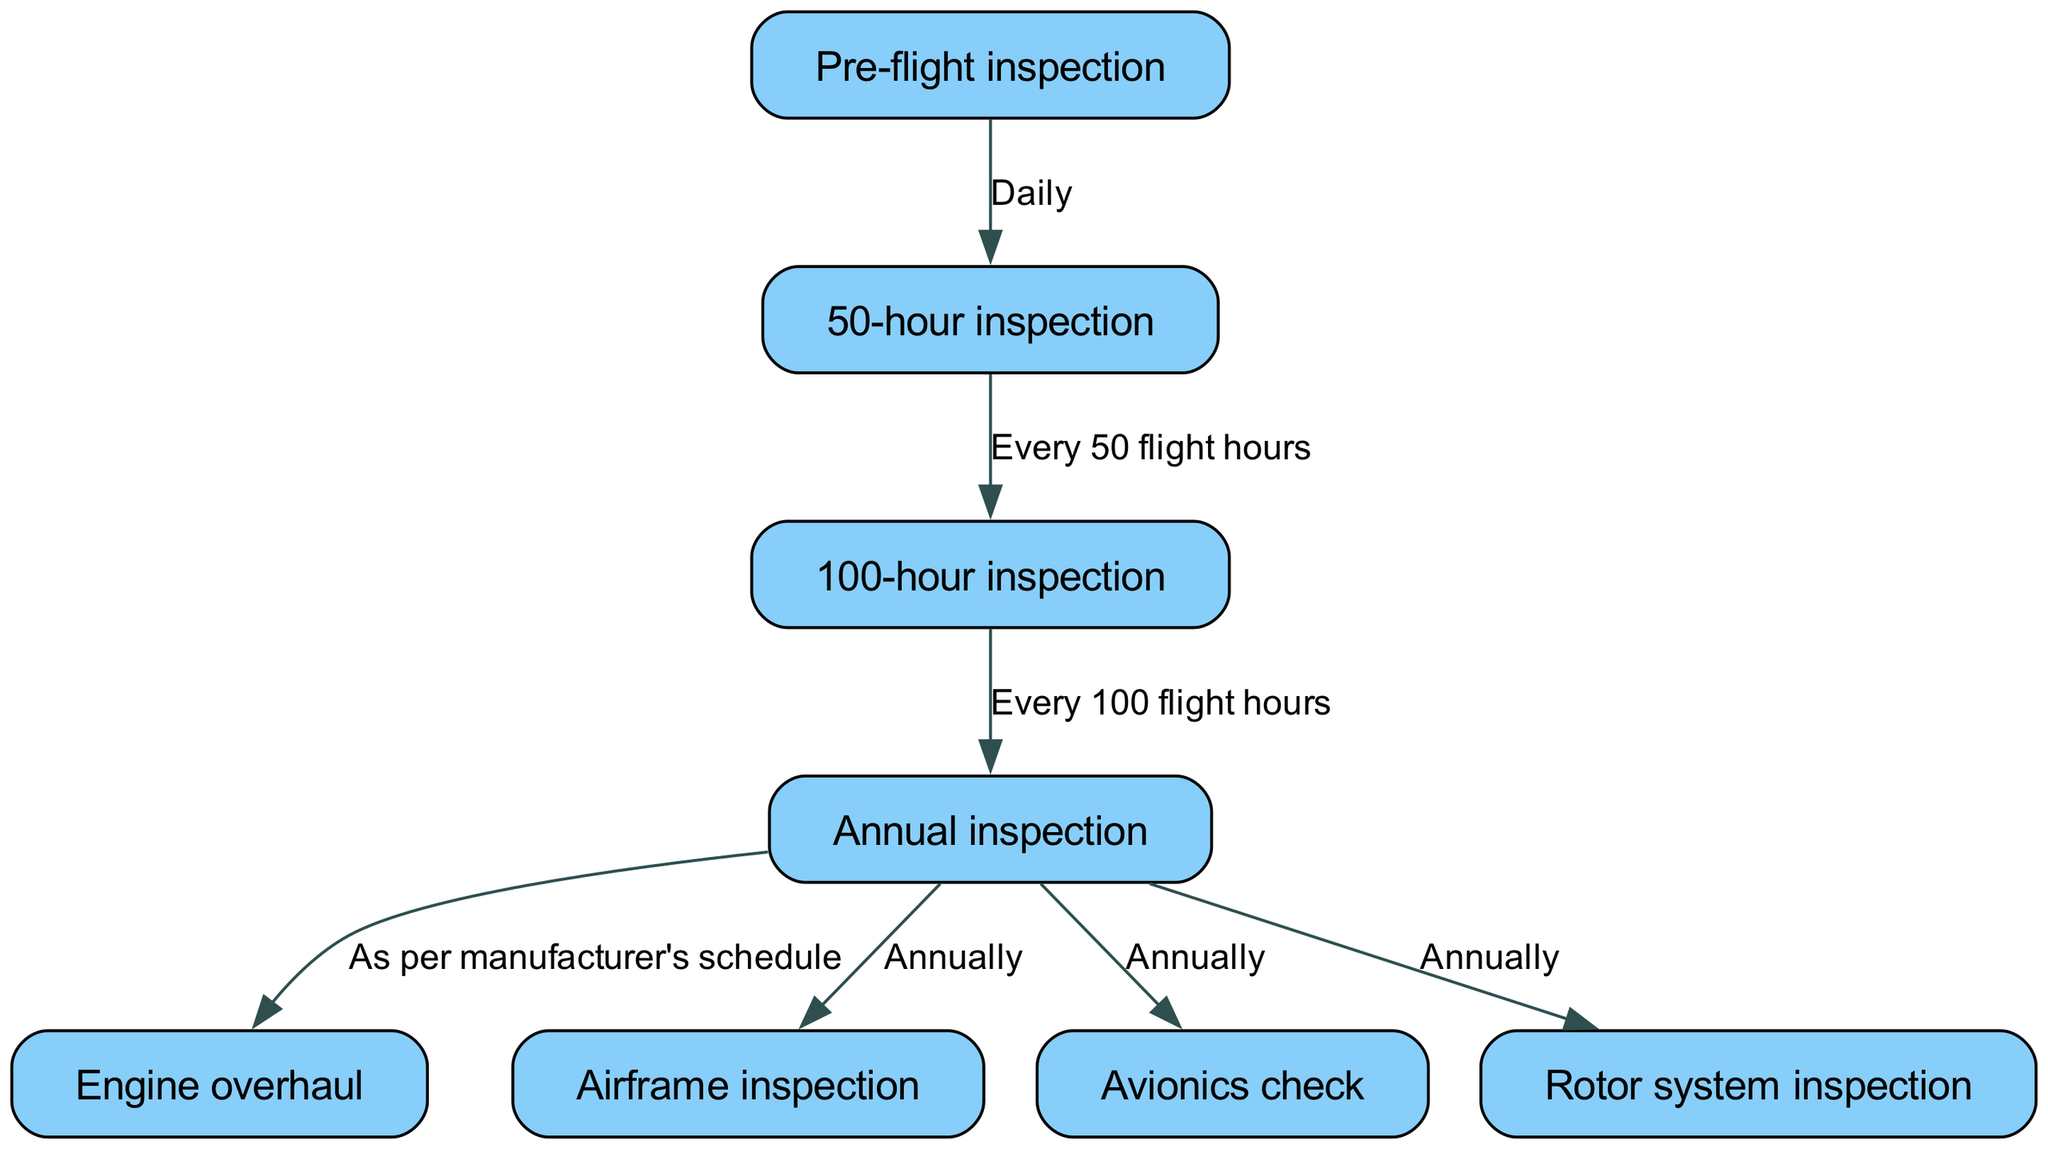What is the first task in the maintenance workflow? The diagram shows that the first task is the "Pre-flight inspection," indicated as the starting node in the path.
Answer: Pre-flight inspection How often is the 100-hour inspection scheduled? The diagram states that the 100-hour inspection occurs "Every 100 flight hours," as shown by the edge connecting the 50-hour inspection to the 100-hour inspection.
Answer: Every 100 flight hours What inspection comes after the annual inspection? According to the diagram, there is no direct inspection listed after the annual inspection; instead, it is linked to the "Engine overhaul," indicating it depends on the manufacturer's schedule.
Answer: Engine overhaul How many main inspections are illustrated in the diagram? The diagram lists a total of 6 main inspections, including Pre-flight, 50-hour, 100-hour, Annual, Engine overhaul, and Airframe inspection. Counting the direct nodes gives us this number.
Answer: 6 What is the frequency of the avionics check? The diagram indicates that the avionics check occurs "Annually," as shown by the direct connection from the annual inspection to the avionics check.
Answer: Annually Which inspection is performed daily? The diagram specifies that the "Pre-flight inspection" is the only inspection conducted daily, as it is the first node connected to subsequent nodes in the maintenance schedule.
Answer: Daily What follows the 50-hour inspection in the workflow? The diagram shows that the 50-hour inspection is followed by the 100-hour inspection, as indicated by the arrow going from the 50-hour inspection to the 100-hour inspection labeled "Every 50 flight hours."
Answer: 100-hour inspection How are the annual inspections related to the other inspections? The diagram connects the annual inspection to three outcomes: "Airframe inspection," "Avionics check," and "Rotor system inspection," showing that these tasks are performed annually following the annual inspection.
Answer: Three inspections What determines when the engine overhaul will take place? The diagram indicates that the engine overhaul is determined "As per manufacturer's schedule," meaning it relies on the specific guidelines provided by the helicopter's manufacturer instead of a fixed time frame.
Answer: Manufacturer's schedule 